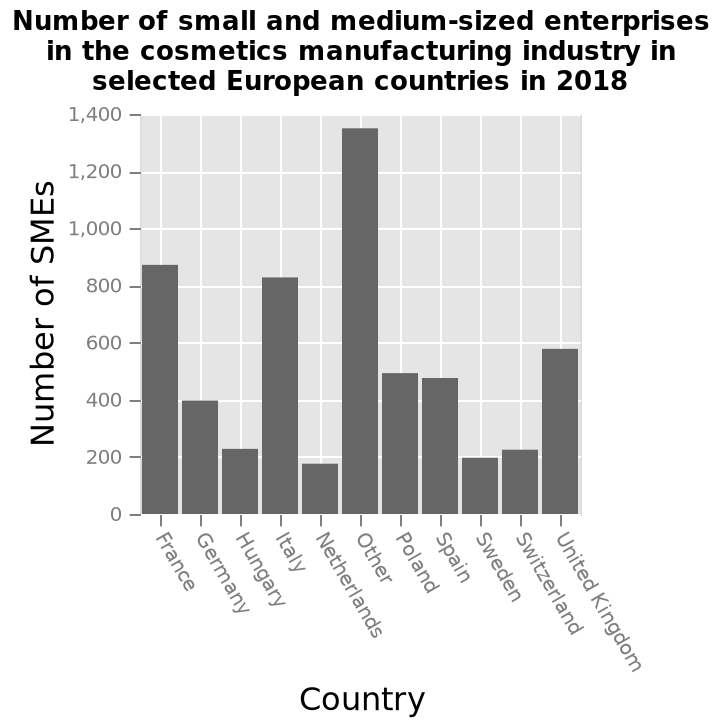<image>
Which year is the data from? The data is from 2018. 